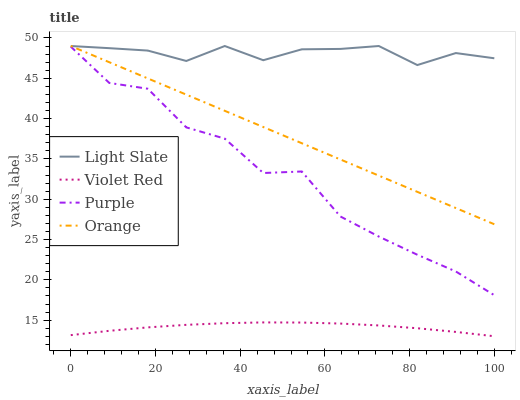Does Violet Red have the minimum area under the curve?
Answer yes or no. Yes. Does Light Slate have the maximum area under the curve?
Answer yes or no. Yes. Does Purple have the minimum area under the curve?
Answer yes or no. No. Does Purple have the maximum area under the curve?
Answer yes or no. No. Is Orange the smoothest?
Answer yes or no. Yes. Is Purple the roughest?
Answer yes or no. Yes. Is Violet Red the smoothest?
Answer yes or no. No. Is Violet Red the roughest?
Answer yes or no. No. Does Violet Red have the lowest value?
Answer yes or no. Yes. Does Purple have the lowest value?
Answer yes or no. No. Does Orange have the highest value?
Answer yes or no. Yes. Does Purple have the highest value?
Answer yes or no. No. Is Violet Red less than Orange?
Answer yes or no. Yes. Is Orange greater than Purple?
Answer yes or no. Yes. Does Light Slate intersect Orange?
Answer yes or no. Yes. Is Light Slate less than Orange?
Answer yes or no. No. Is Light Slate greater than Orange?
Answer yes or no. No. Does Violet Red intersect Orange?
Answer yes or no. No. 